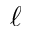Convert formula to latex. <formula><loc_0><loc_0><loc_500><loc_500>\ell</formula> 